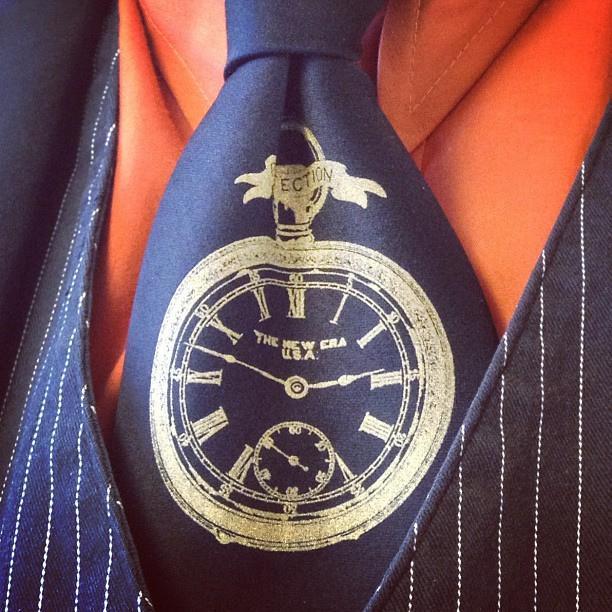How many people are on this ski lift?
Give a very brief answer. 0. 